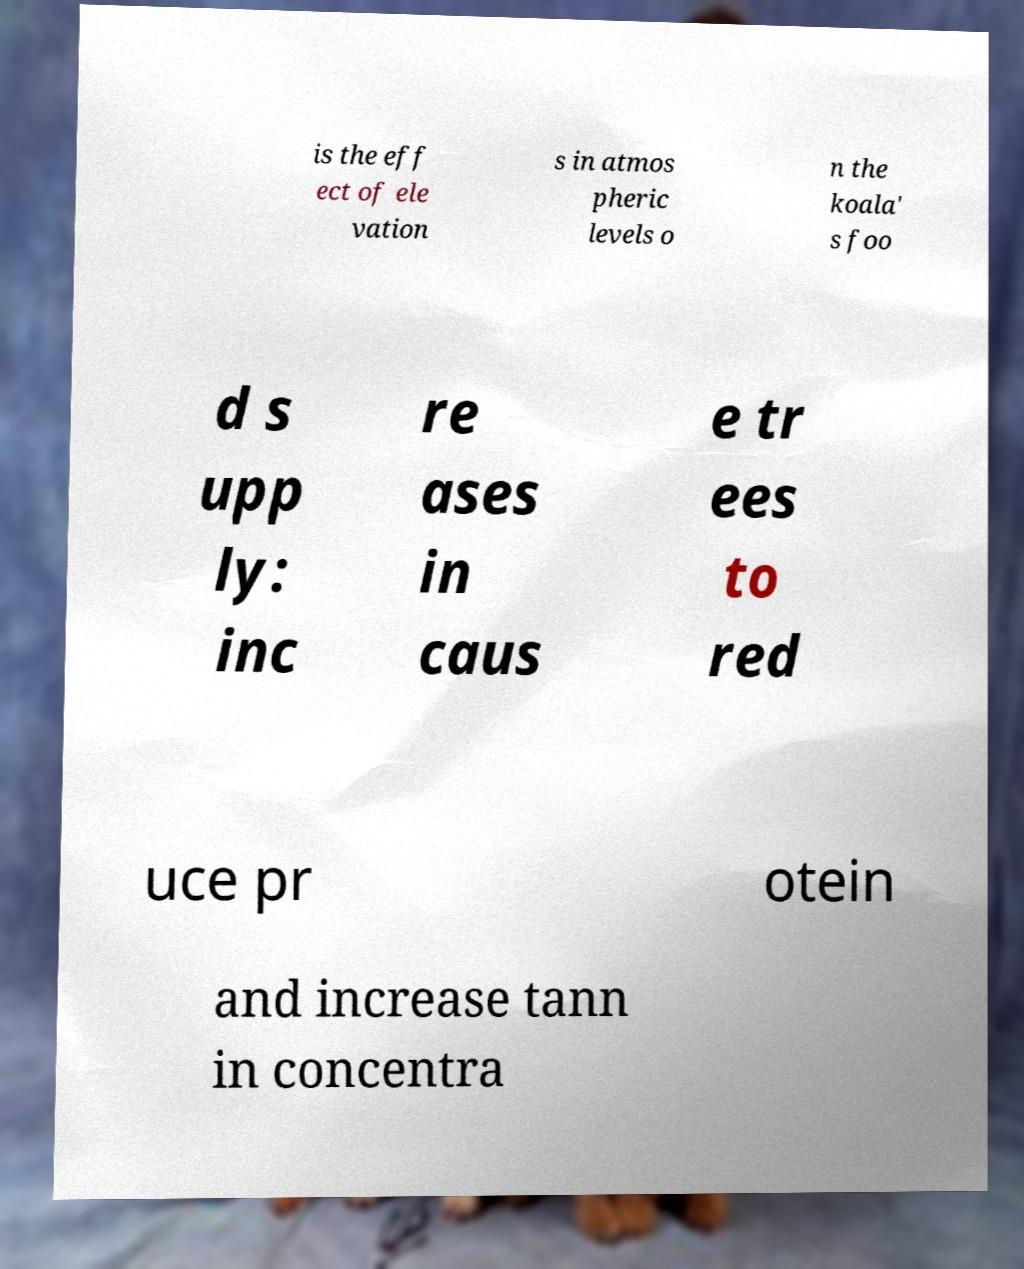Could you assist in decoding the text presented in this image and type it out clearly? is the eff ect of ele vation s in atmos pheric levels o n the koala' s foo d s upp ly: inc re ases in caus e tr ees to red uce pr otein and increase tann in concentra 